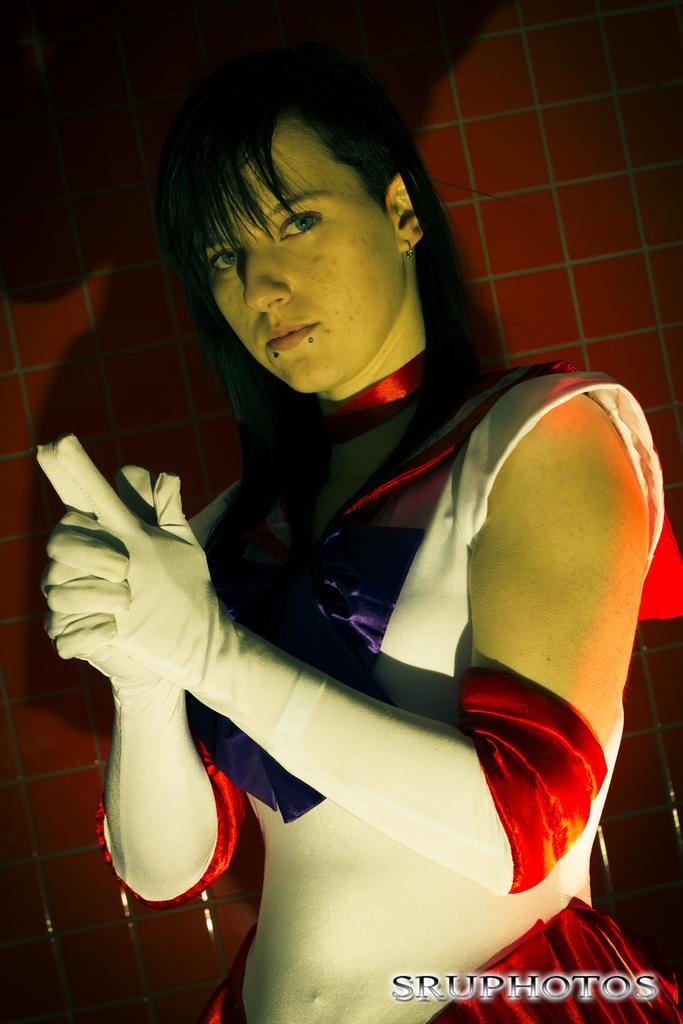Could you give a brief overview of what you see in this image? In this image I can see a woman wearing red, violet and white colored dress is stunning. In the background I can see the brown colored wall. 